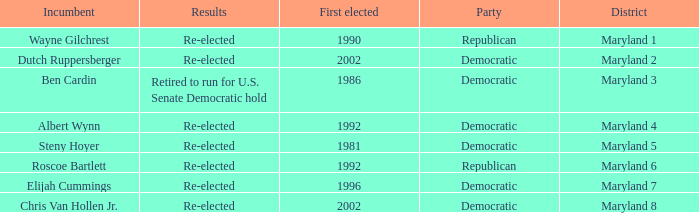Who is the incumbent who was first elected before 2002 from the maryland 3 district? Ben Cardin. 